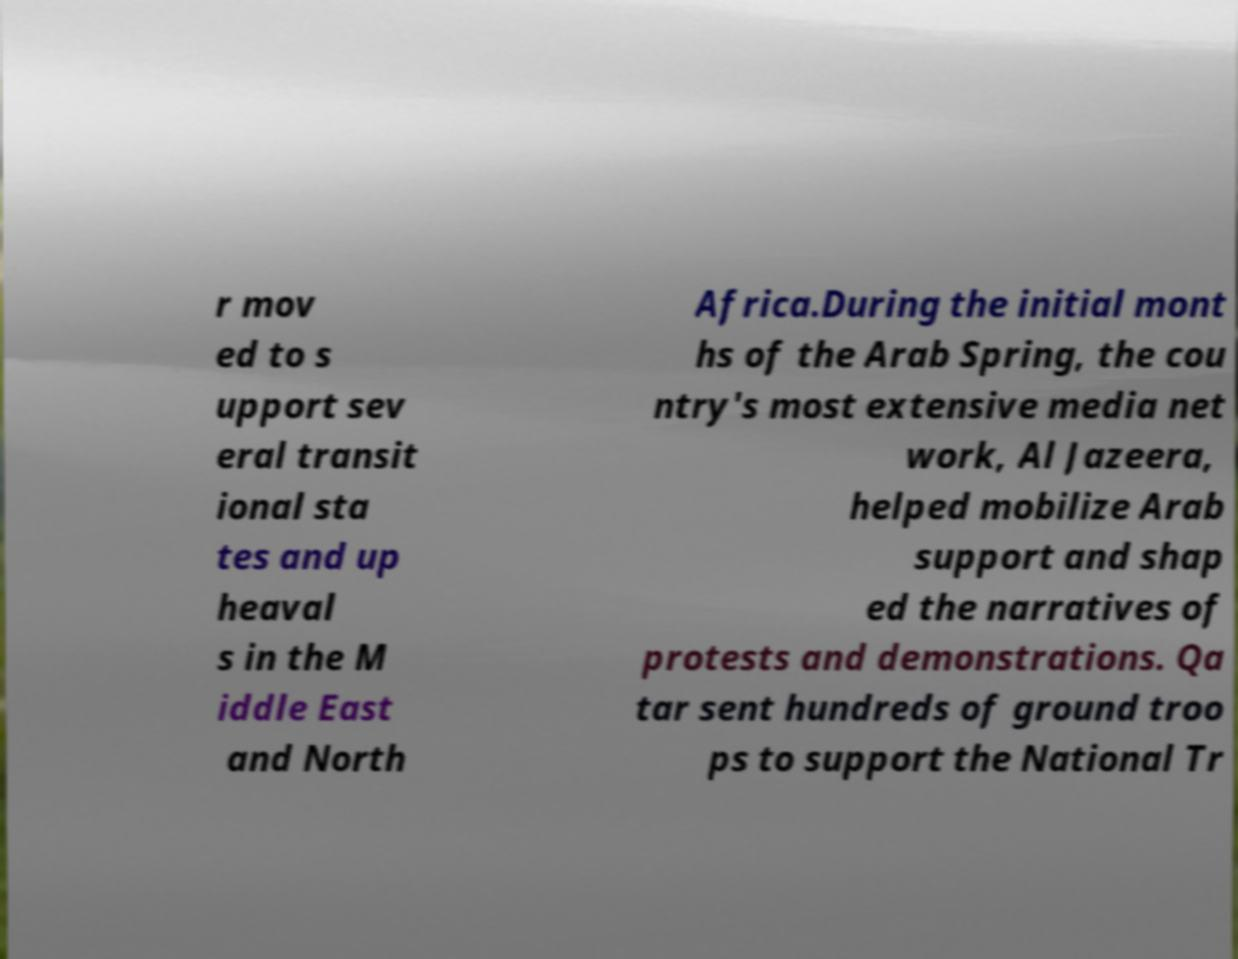Can you read and provide the text displayed in the image?This photo seems to have some interesting text. Can you extract and type it out for me? r mov ed to s upport sev eral transit ional sta tes and up heaval s in the M iddle East and North Africa.During the initial mont hs of the Arab Spring, the cou ntry's most extensive media net work, Al Jazeera, helped mobilize Arab support and shap ed the narratives of protests and demonstrations. Qa tar sent hundreds of ground troo ps to support the National Tr 